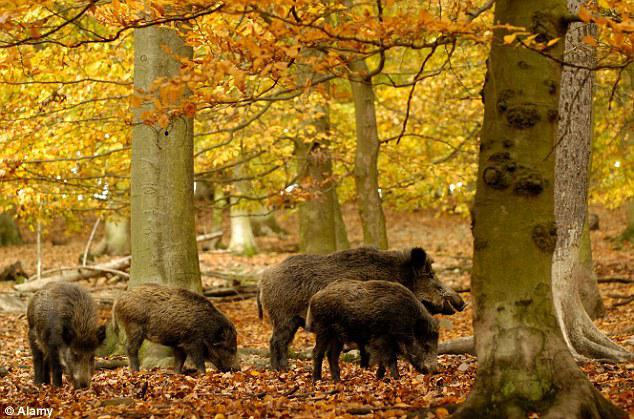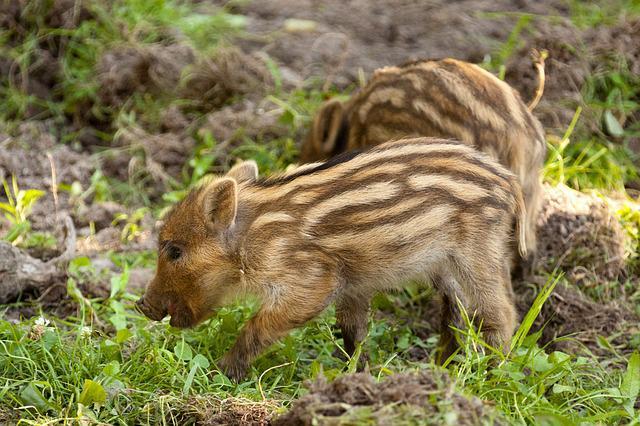The first image is the image on the left, the second image is the image on the right. For the images shown, is this caption "There is a single boar in the left image." true? Answer yes or no. No. The first image is the image on the left, the second image is the image on the right. For the images displayed, is the sentence "In one of the images there are two or more brown striped pigs." factually correct? Answer yes or no. Yes. 